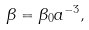<formula> <loc_0><loc_0><loc_500><loc_500>\beta = \beta _ { 0 } a ^ { - 3 } ,</formula> 